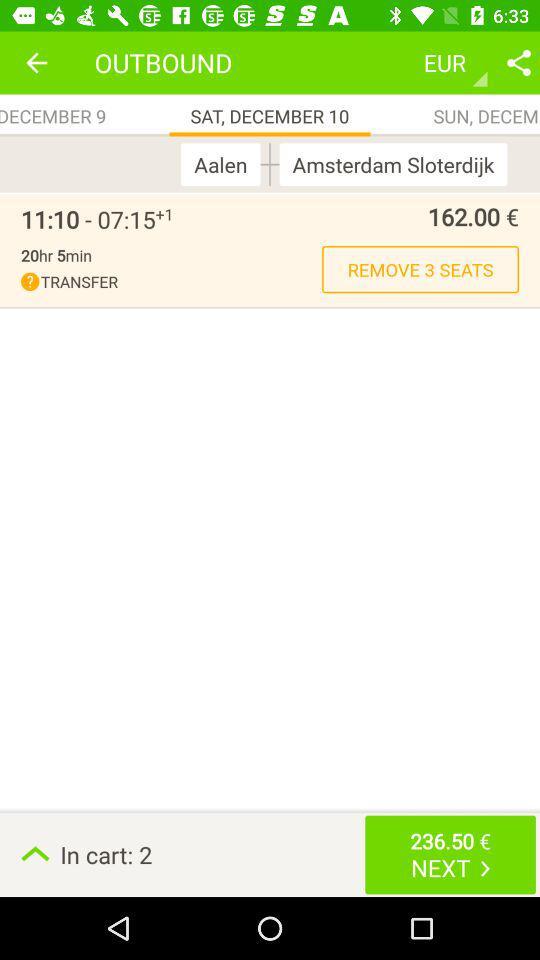What year is shown on the screen?
When the provided information is insufficient, respond with <no answer>. <no answer> 